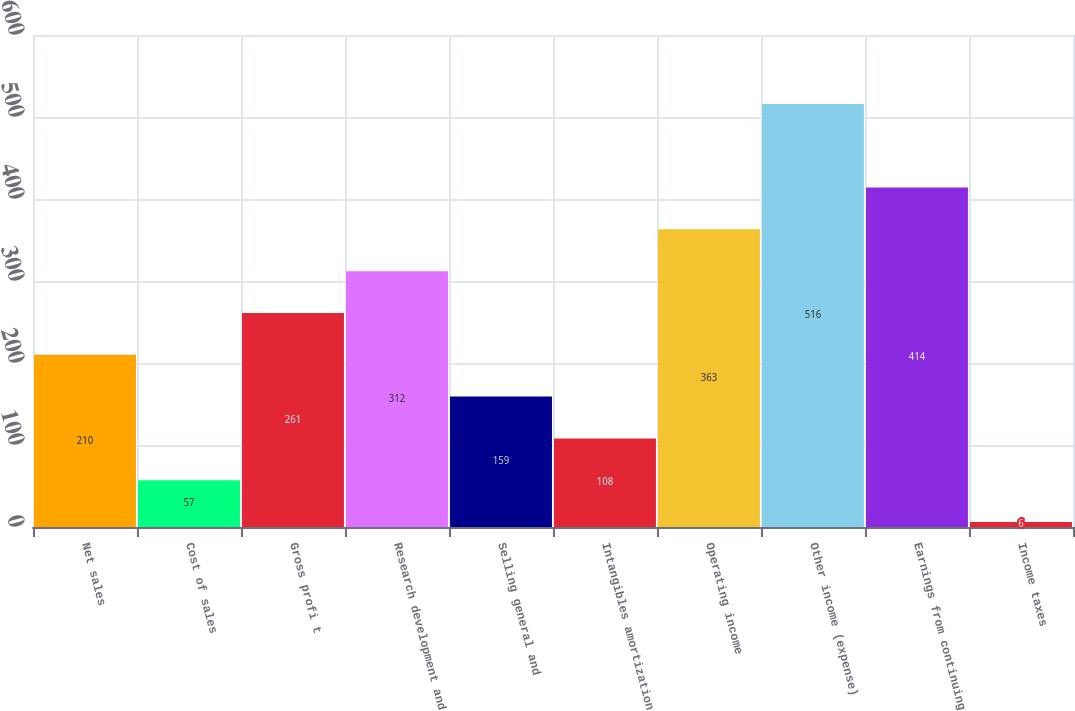Convert chart to OTSL. <chart><loc_0><loc_0><loc_500><loc_500><bar_chart><fcel>Net sales<fcel>Cost of sales<fcel>Gross profi t<fcel>Research development and<fcel>Selling general and<fcel>Intangibles amortization<fcel>Operating income<fcel>Other income (expense)<fcel>Earnings from continuing<fcel>Income taxes<nl><fcel>210<fcel>57<fcel>261<fcel>312<fcel>159<fcel>108<fcel>363<fcel>516<fcel>414<fcel>6<nl></chart> 